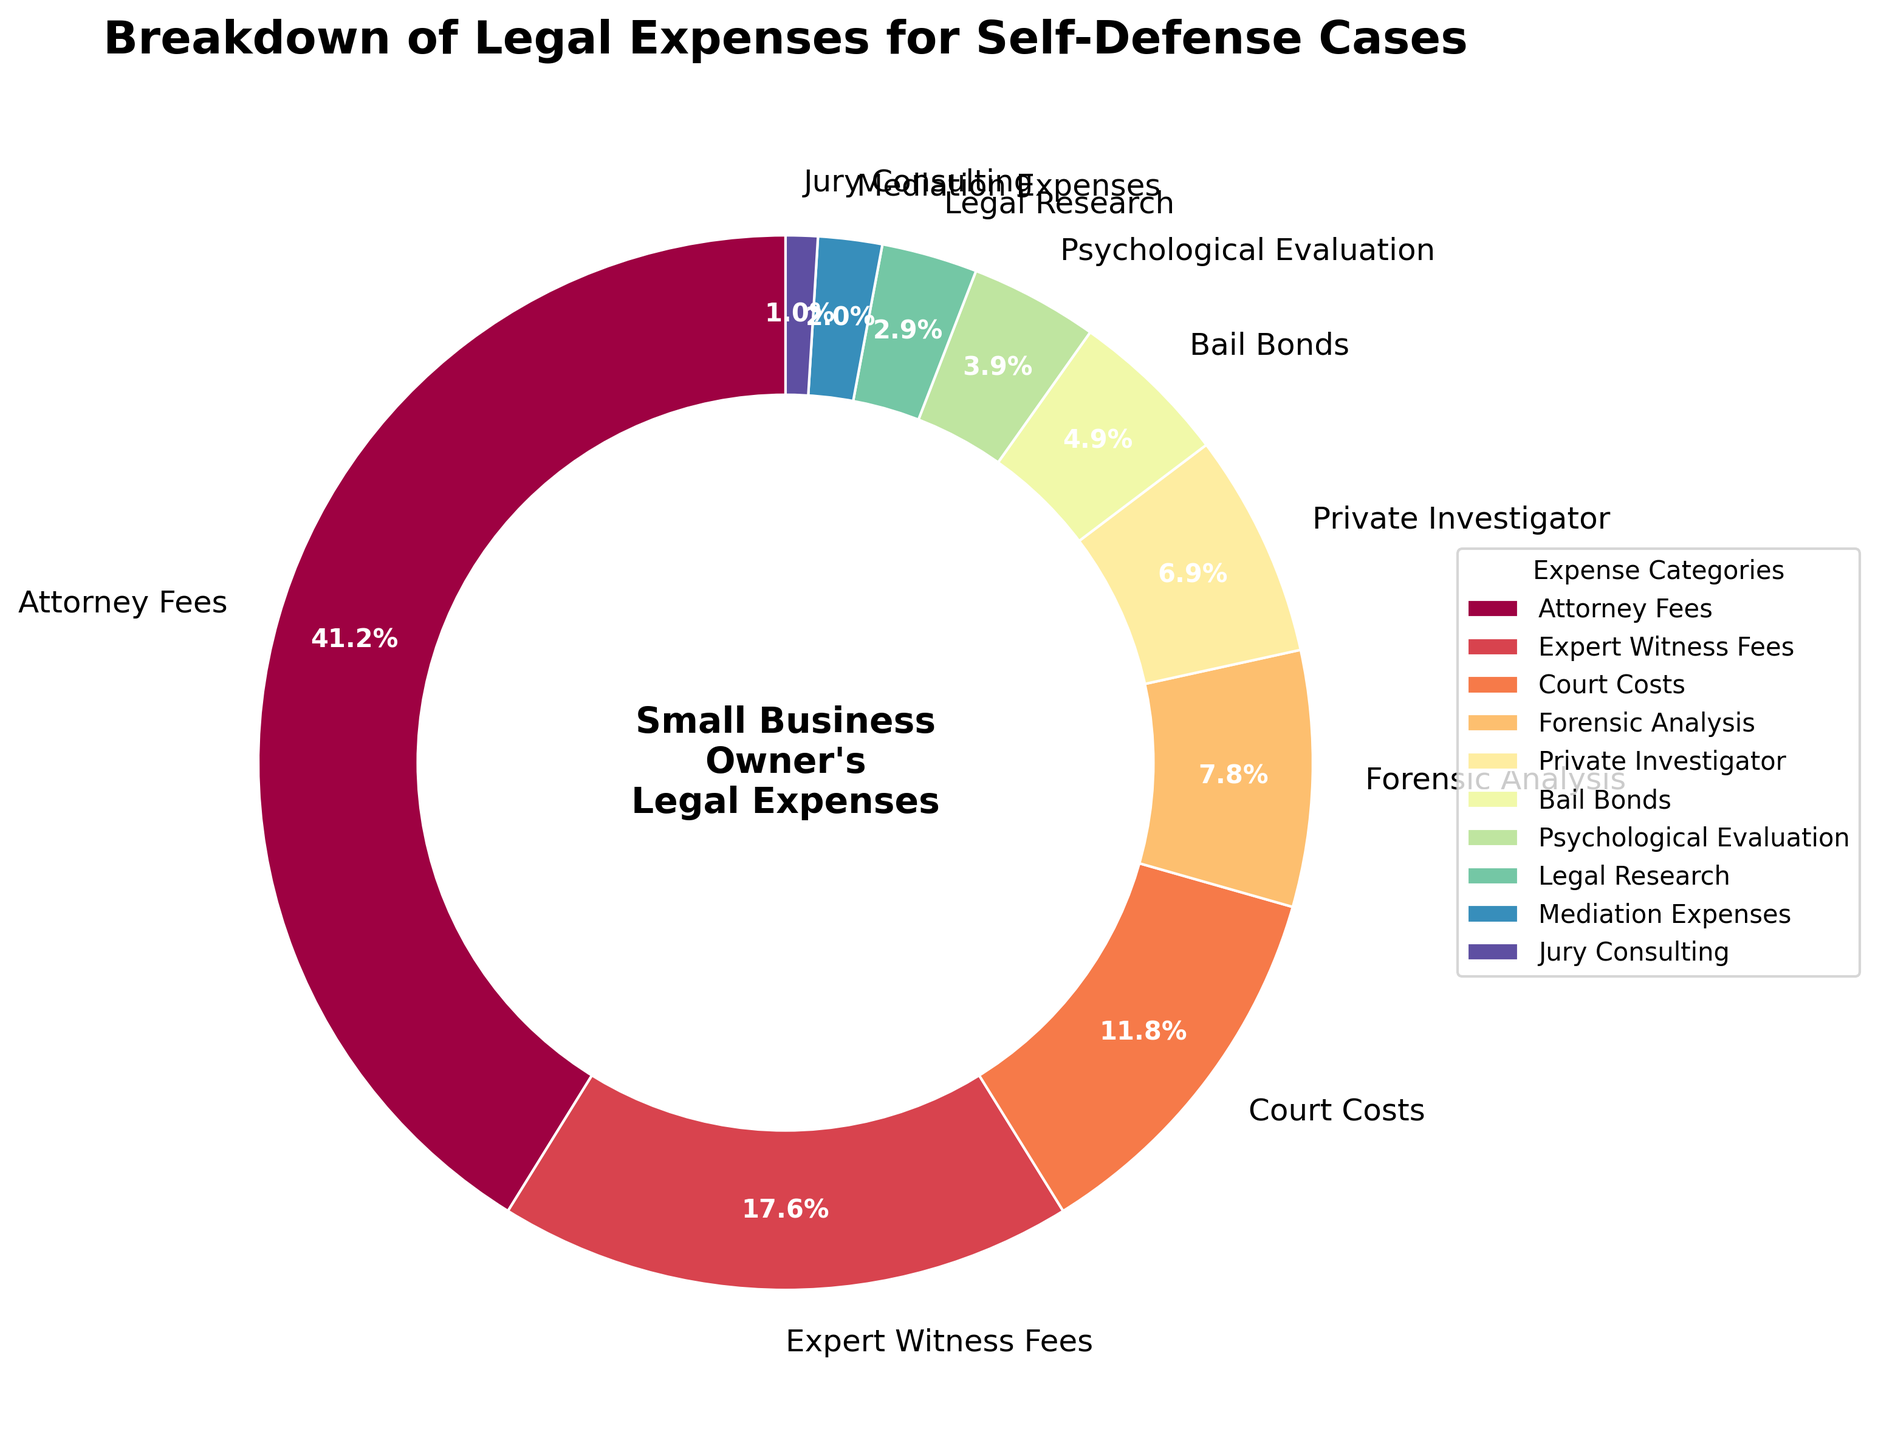What's the largest category of legal expenses? The chart shows several legal expense categories, each with a different percentage. The largest percentage corresponds to Attorney Fees at 42%.
Answer: Attorney Fees Which category has the smallest percentage? By looking at the segments of the pie chart, the smallest slice corresponds to Jury Consulting at 1%.
Answer: Jury Consulting How do Attorney Fees compare to Expert Witness Fees in terms of percentage? Attorney Fees have a percentage of 42%, whereas Expert Witness Fees account for 18%. Attorney Fees are therefore larger than Expert Witness Fees by 24%.
Answer: Attorney Fees are 24% larger What is the combined percentage of Court Costs, Bail Bonds, and Legal Research? Court Costs are 12%, Bail Bonds are 5%, and Legal Research are 3%. Adding these, 12 + 5 + 3 = 20%.
Answer: 20% Which expense category is represented by a light green color? The pie chart uses distinct colors for each category. The segment with the light green color is labeled as Forensic Analysis, which accounts for 8%.
Answer: Forensic Analysis If you combine the percentages of the three smallest categories, what do you get? The three smallest categories are Jury Consulting (1%), Mediation Expenses (2%), and Legal Research (3%). Adding these percentages: 1 + 2 + 3 = 6%.
Answer: 6% Which two categories together make up more than half of the expenses? Attorney Fees (42%) and Expert Witness Fees (18%) are the two largest categories. Combined, their percentage is 42 + 18 = 60%, which is more than half.
Answer: Attorney Fees and Expert Witness Fees Compare the percentages of Forensic Analysis and Private Investigator. Which one is higher and by how much? Forensic Analysis is 8%, and Private Investigator is 7%. Forensic Analysis is higher by 1%.
Answer: Forensic Analysis by 1% What is the difference in percentage between Bail Bonds and Psychological Evaluation? Bail Bonds are at 5%, and Psychological Evaluation is at 4%. The difference is 5 - 4 = 1%.
Answer: 1% What is the total percentage of all categories except for Attorney Fees? The total percentage of all categories is 100%. Subtracting the Attorney Fees (42%), we get 100 - 42 = 58%.
Answer: 58% 